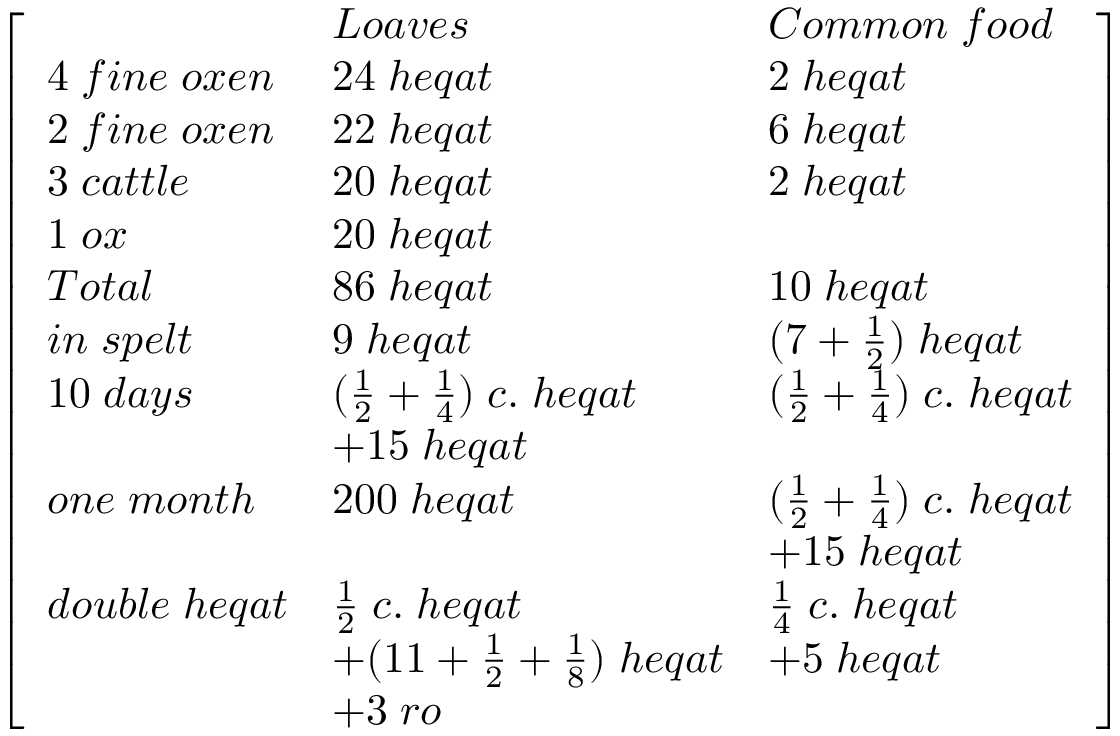Convert formula to latex. <formula><loc_0><loc_0><loc_500><loc_500>{ \left [ \begin{array} { l l l } & { L o a v e s } & { C o m m o n \, f o o d } \\ { 4 \, f i n e \, o x e n } & { 2 4 \, h e q a t } & { 2 \, h e q a t } \\ { 2 \, f i n e \, o x e n } & { 2 2 \, h e q a t } & { 6 \, h e q a t } \\ { 3 \, c a t t l e } & { 2 0 \, h e q a t } & { 2 \, h e q a t } \\ { 1 \, o x } & { 2 0 \, h e q a t } & \\ { T o t a l } & { 8 6 \, h e q a t } & { 1 0 \, h e q a t } \\ { i n \, s p e l t } & { 9 \, h e q a t } & { ( 7 + { \frac { 1 } { 2 } } ) \, h e q a t } \\ { 1 0 \, d a y s } & { ( { \frac { 1 } { 2 } } + { \frac { 1 } { 4 } } ) \, c . \, h e q a t } & { ( { \frac { 1 } { 2 } } + { \frac { 1 } { 4 } } ) \, c . \, h e q a t } \\ & { + 1 5 \, h e q a t } & \\ { o n e \, m o n t h } & { 2 0 0 \, h e q a t } & { ( { \frac { 1 } { 2 } } + { \frac { 1 } { 4 } } ) \, c . \, h e q a t } \\ & & { + 1 5 \, h e q a t } \\ { d o u b l e \, h e q a t } & { { \frac { 1 } { 2 } } \, c . \, h e q a t } & { { \frac { 1 } { 4 } } \, c . \, h e q a t } \\ & { + ( 1 1 + { \frac { 1 } { 2 } } + { \frac { 1 } { 8 } } ) \, h e q a t } & { + 5 \, h e q a t } \\ & { + 3 \, r o } & \end{array} \right ] }</formula> 